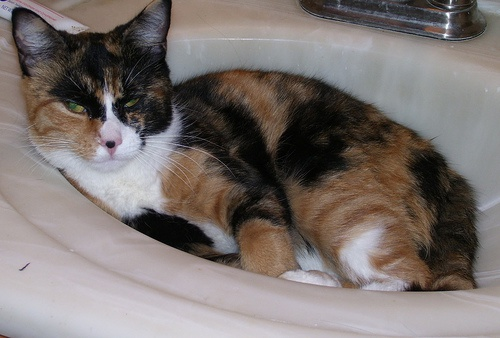Describe the objects in this image and their specific colors. I can see sink in darkgray, black, and gray tones and cat in gray, black, and maroon tones in this image. 